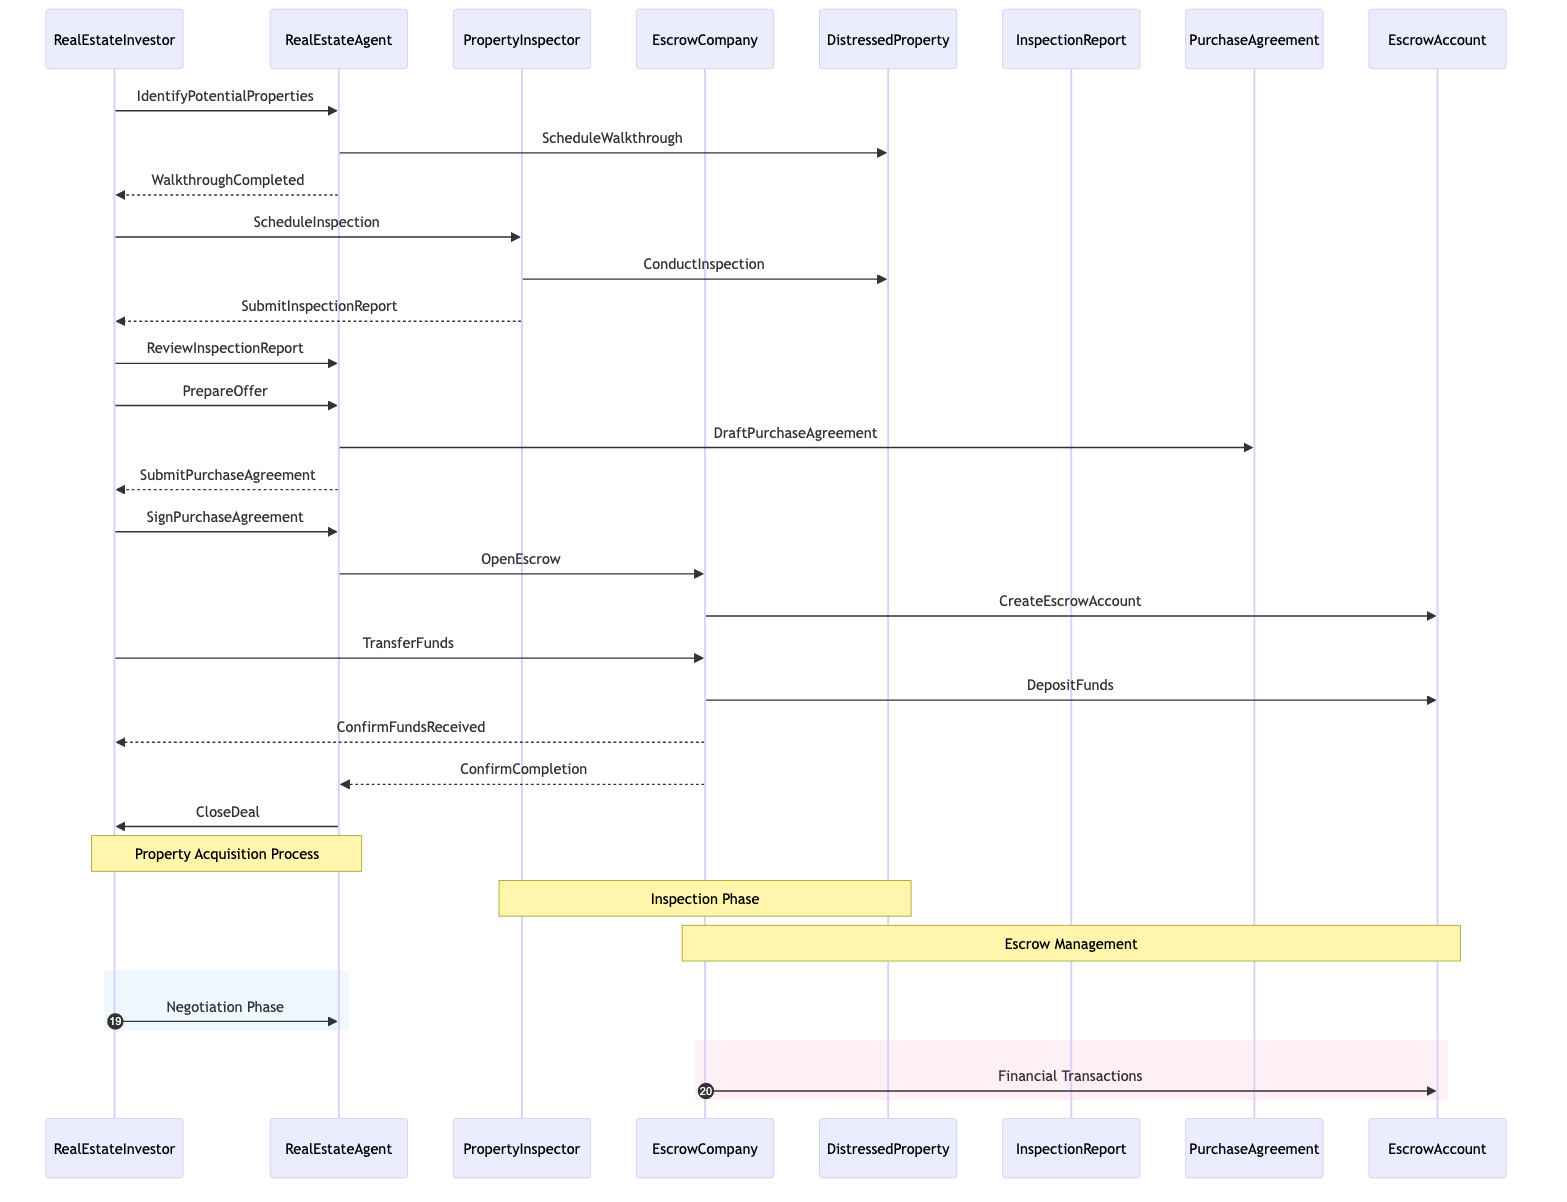What is the first action taken by the investor? The first action taken by the Real Estate Investor is to identify potential properties, which is shown as the first message in the sequence diagram.
Answer: IdentifyPotentialProperties Who conducts the inspection? The Property Inspector conducts the inspection of the distressed property as indicated in the diagram, specifically connected to the ConductInspection message.
Answer: PropertyInspector How many main actors are involved in the process? There are four main actors involved: Real Estate Investor, Real Estate Agent, Property Inspector, and Escrow Company. This can be confirmed by counting the participants in the diagram.
Answer: Four What document is drafted after the offer is prepared? The Purchase Agreement is drafted after the investor prepares the offer, illustrated by the message from the Real Estate Agent to the Purchase Agreement.
Answer: PurchaseAgreement What step follows the submission of the purchase agreement? After the submission of the purchase agreement, the next step is for the Real Estate Investor to sign the purchase agreement. This is depicted in the sequence of messages following the submit purchase agreement.
Answer: SignPurchaseAgreement What confirms that funds were received by the escrow company? The confirmation of funds received is indicated through the message from the Escrow Company to the Real Estate Investor labeled ConfirmFundsReceived.
Answer: ConfirmFundsReceived What phase involves the Property Inspector and Distressed Property? The Inspection Phase involves the Property Inspector and the Distressed Property, as highlighted by the note over those two participants in the diagram.
Answer: Inspection Phase Which entity handles the financial transactions in the diagram? The Escrow Company handles the financial transactions. This is clarified in the section labeled Financial Transactions within the diagram where various fund-related messages are shown.
Answer: EscrowCompany How is the deal ultimately closed? The deal is ultimately closed through a message indicating CloseDeal sent from the Real Estate Agent to the Real Estate Investor. This denotes the completion of the purchasing process.
Answer: CloseDeal What happens immediately after the escrow is opened? Immediately after the escrow is opened, an escrow account is created by the escrow company, as shown in the sequence of messages following the OpenEscrow action.
Answer: CreateEscrowAccount 